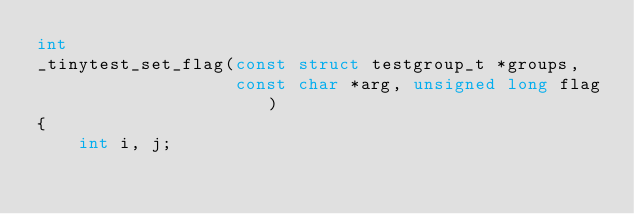Convert code to text. <code><loc_0><loc_0><loc_500><loc_500><_C++_>int
_tinytest_set_flag(const struct testgroup_t *groups,
                   const char *arg, unsigned long flag)
{
	int i, j;</code> 